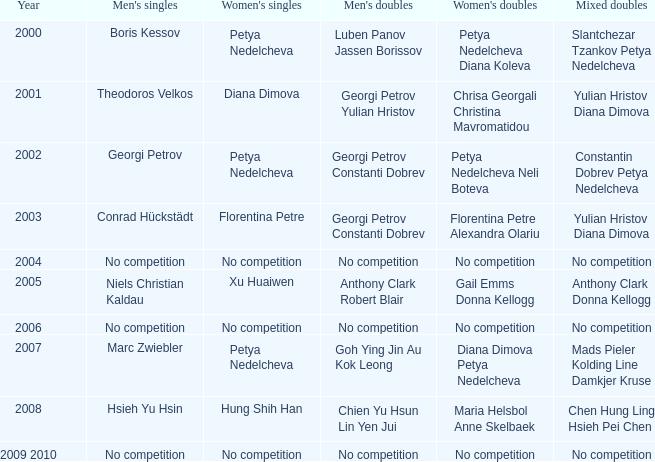In what year was there no competition for women? 2004, 2006, 2009 2010. 